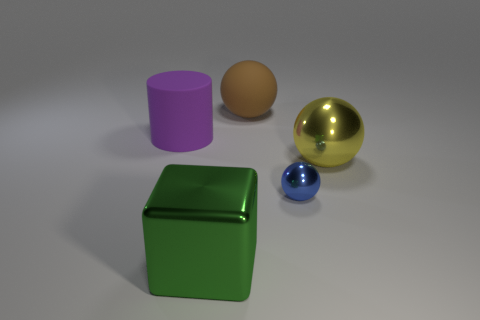Add 4 metal cubes. How many objects exist? 9 Subtract all balls. How many objects are left? 2 Subtract 0 cyan cubes. How many objects are left? 5 Subtract all small purple cubes. Subtract all large spheres. How many objects are left? 3 Add 1 big yellow spheres. How many big yellow spheres are left? 2 Add 1 large yellow balls. How many large yellow balls exist? 2 